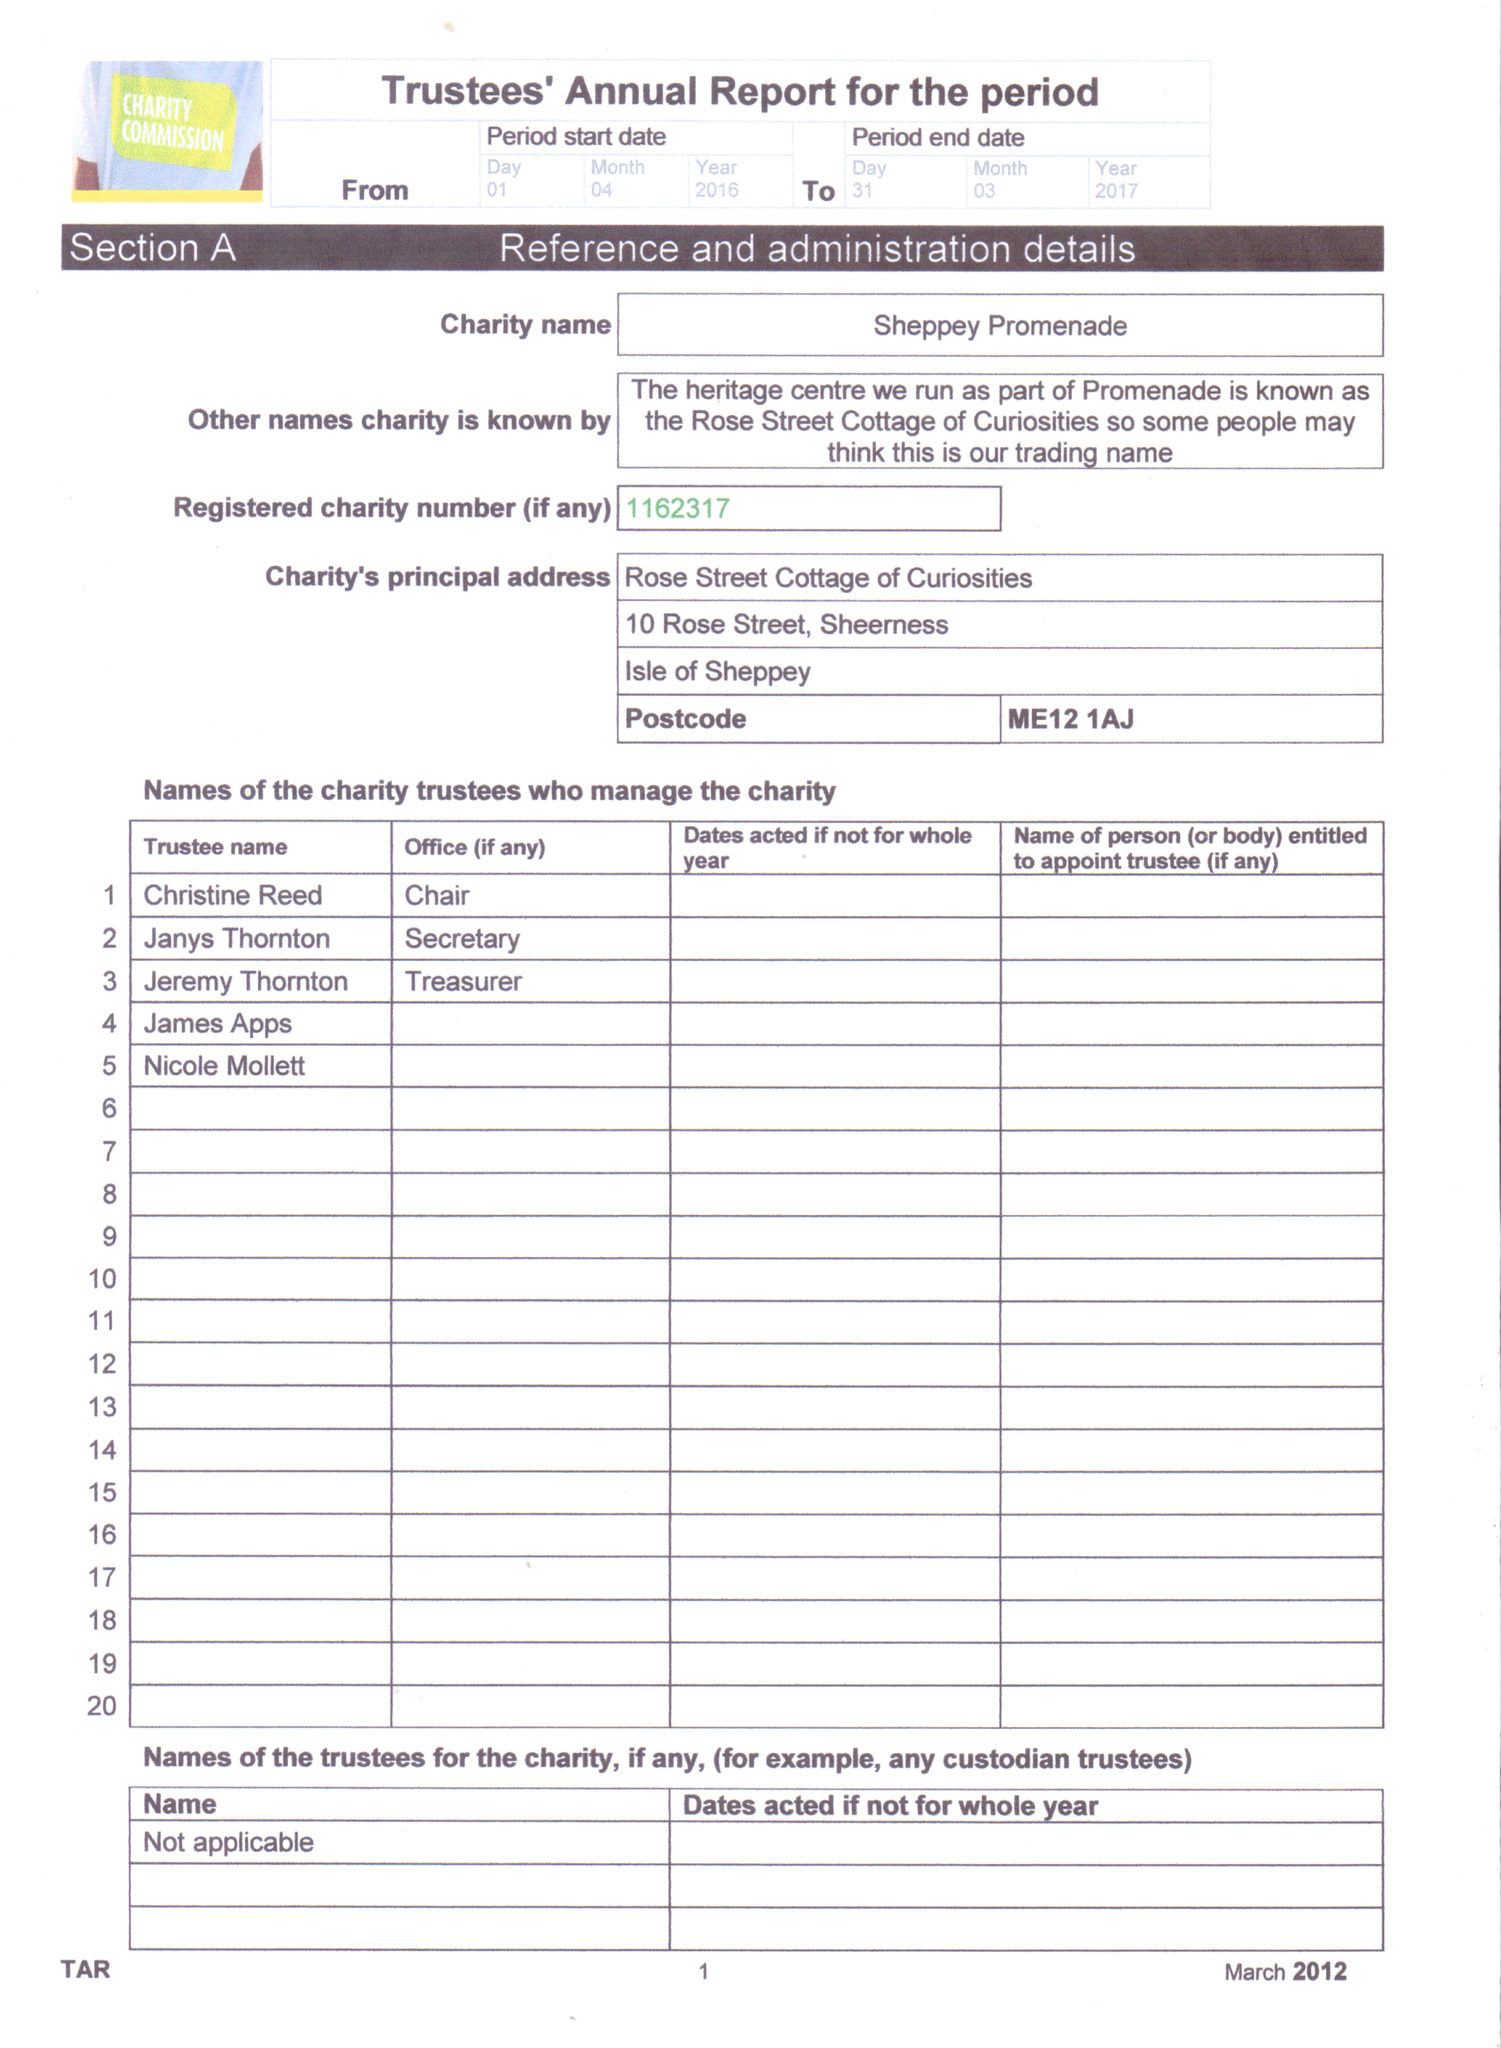What is the value for the address__post_town?
Answer the question using a single word or phrase. SHEERNESS 